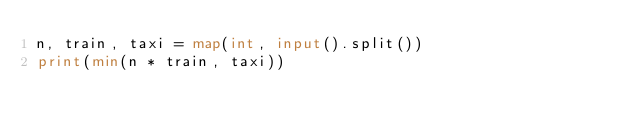Convert code to text. <code><loc_0><loc_0><loc_500><loc_500><_Python_>n, train, taxi = map(int, input().split())
print(min(n * train, taxi))</code> 